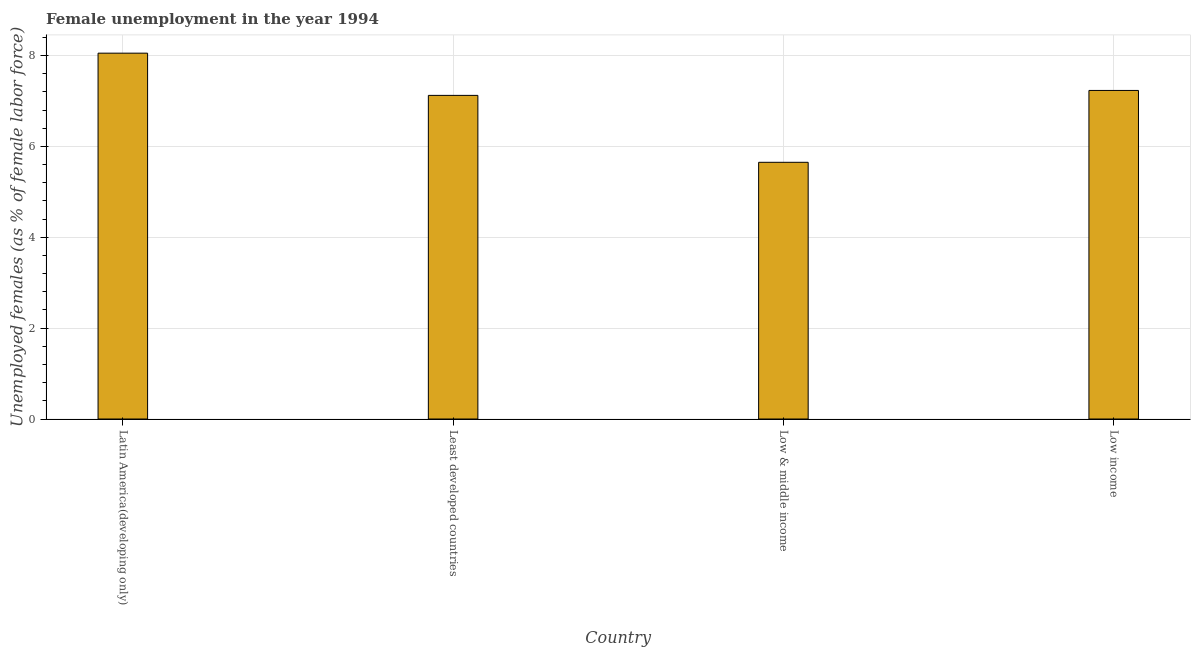Does the graph contain grids?
Your answer should be very brief. Yes. What is the title of the graph?
Your answer should be compact. Female unemployment in the year 1994. What is the label or title of the X-axis?
Your answer should be compact. Country. What is the label or title of the Y-axis?
Give a very brief answer. Unemployed females (as % of female labor force). What is the unemployed females population in Low income?
Provide a short and direct response. 7.23. Across all countries, what is the maximum unemployed females population?
Provide a succinct answer. 8.05. Across all countries, what is the minimum unemployed females population?
Provide a short and direct response. 5.65. In which country was the unemployed females population maximum?
Give a very brief answer. Latin America(developing only). What is the sum of the unemployed females population?
Offer a very short reply. 28.06. What is the difference between the unemployed females population in Latin America(developing only) and Low income?
Offer a very short reply. 0.82. What is the average unemployed females population per country?
Offer a very short reply. 7.02. What is the median unemployed females population?
Make the answer very short. 7.18. What is the ratio of the unemployed females population in Latin America(developing only) to that in Low income?
Keep it short and to the point. 1.11. Is the unemployed females population in Least developed countries less than that in Low income?
Your response must be concise. Yes. Is the difference between the unemployed females population in Latin America(developing only) and Low & middle income greater than the difference between any two countries?
Make the answer very short. Yes. What is the difference between the highest and the second highest unemployed females population?
Keep it short and to the point. 0.82. What is the difference between the highest and the lowest unemployed females population?
Give a very brief answer. 2.4. How many bars are there?
Provide a short and direct response. 4. What is the difference between two consecutive major ticks on the Y-axis?
Keep it short and to the point. 2. What is the Unemployed females (as % of female labor force) in Latin America(developing only)?
Give a very brief answer. 8.05. What is the Unemployed females (as % of female labor force) in Least developed countries?
Keep it short and to the point. 7.12. What is the Unemployed females (as % of female labor force) of Low & middle income?
Make the answer very short. 5.65. What is the Unemployed females (as % of female labor force) in Low income?
Keep it short and to the point. 7.23. What is the difference between the Unemployed females (as % of female labor force) in Latin America(developing only) and Least developed countries?
Provide a succinct answer. 0.93. What is the difference between the Unemployed females (as % of female labor force) in Latin America(developing only) and Low & middle income?
Make the answer very short. 2.4. What is the difference between the Unemployed females (as % of female labor force) in Latin America(developing only) and Low income?
Provide a short and direct response. 0.82. What is the difference between the Unemployed females (as % of female labor force) in Least developed countries and Low & middle income?
Keep it short and to the point. 1.47. What is the difference between the Unemployed females (as % of female labor force) in Least developed countries and Low income?
Your answer should be compact. -0.11. What is the difference between the Unemployed females (as % of female labor force) in Low & middle income and Low income?
Ensure brevity in your answer.  -1.58. What is the ratio of the Unemployed females (as % of female labor force) in Latin America(developing only) to that in Least developed countries?
Offer a terse response. 1.13. What is the ratio of the Unemployed females (as % of female labor force) in Latin America(developing only) to that in Low & middle income?
Make the answer very short. 1.43. What is the ratio of the Unemployed females (as % of female labor force) in Latin America(developing only) to that in Low income?
Offer a terse response. 1.11. What is the ratio of the Unemployed females (as % of female labor force) in Least developed countries to that in Low & middle income?
Your response must be concise. 1.26. What is the ratio of the Unemployed females (as % of female labor force) in Least developed countries to that in Low income?
Keep it short and to the point. 0.98. What is the ratio of the Unemployed females (as % of female labor force) in Low & middle income to that in Low income?
Provide a succinct answer. 0.78. 